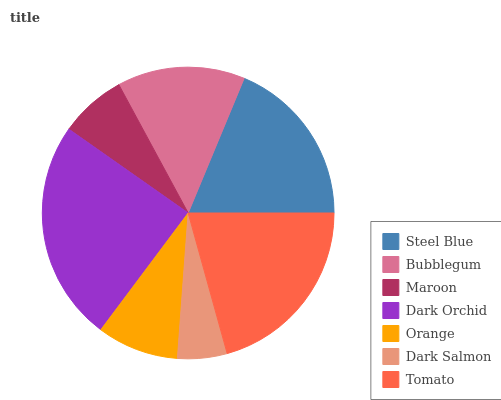Is Dark Salmon the minimum?
Answer yes or no. Yes. Is Dark Orchid the maximum?
Answer yes or no. Yes. Is Bubblegum the minimum?
Answer yes or no. No. Is Bubblegum the maximum?
Answer yes or no. No. Is Steel Blue greater than Bubblegum?
Answer yes or no. Yes. Is Bubblegum less than Steel Blue?
Answer yes or no. Yes. Is Bubblegum greater than Steel Blue?
Answer yes or no. No. Is Steel Blue less than Bubblegum?
Answer yes or no. No. Is Bubblegum the high median?
Answer yes or no. Yes. Is Bubblegum the low median?
Answer yes or no. Yes. Is Maroon the high median?
Answer yes or no. No. Is Dark Orchid the low median?
Answer yes or no. No. 